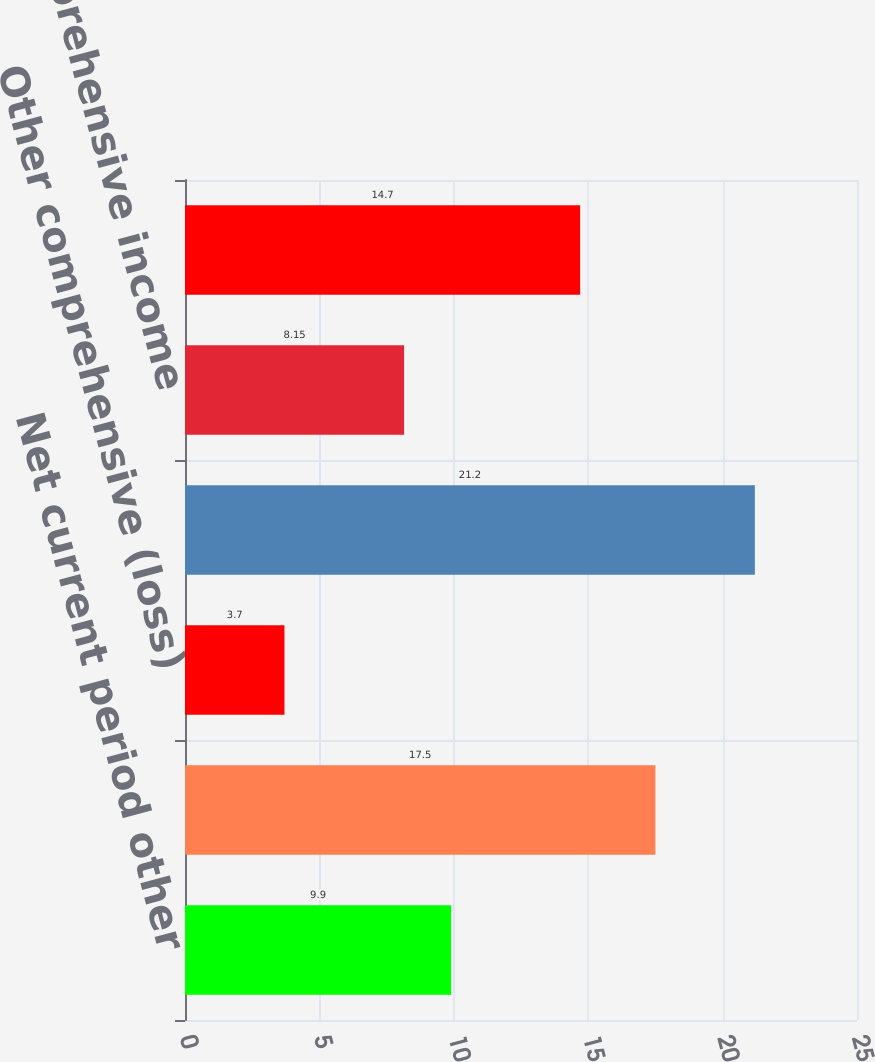Convert chart to OTSL. <chart><loc_0><loc_0><loc_500><loc_500><bar_chart><fcel>Net current period other<fcel>Balance as of December 31 2016<fcel>Other comprehensive (loss)<fcel>Balance as of December 31 2017<fcel>Other comprehensive income<fcel>Balance as of December 31 2018<nl><fcel>9.9<fcel>17.5<fcel>3.7<fcel>21.2<fcel>8.15<fcel>14.7<nl></chart> 